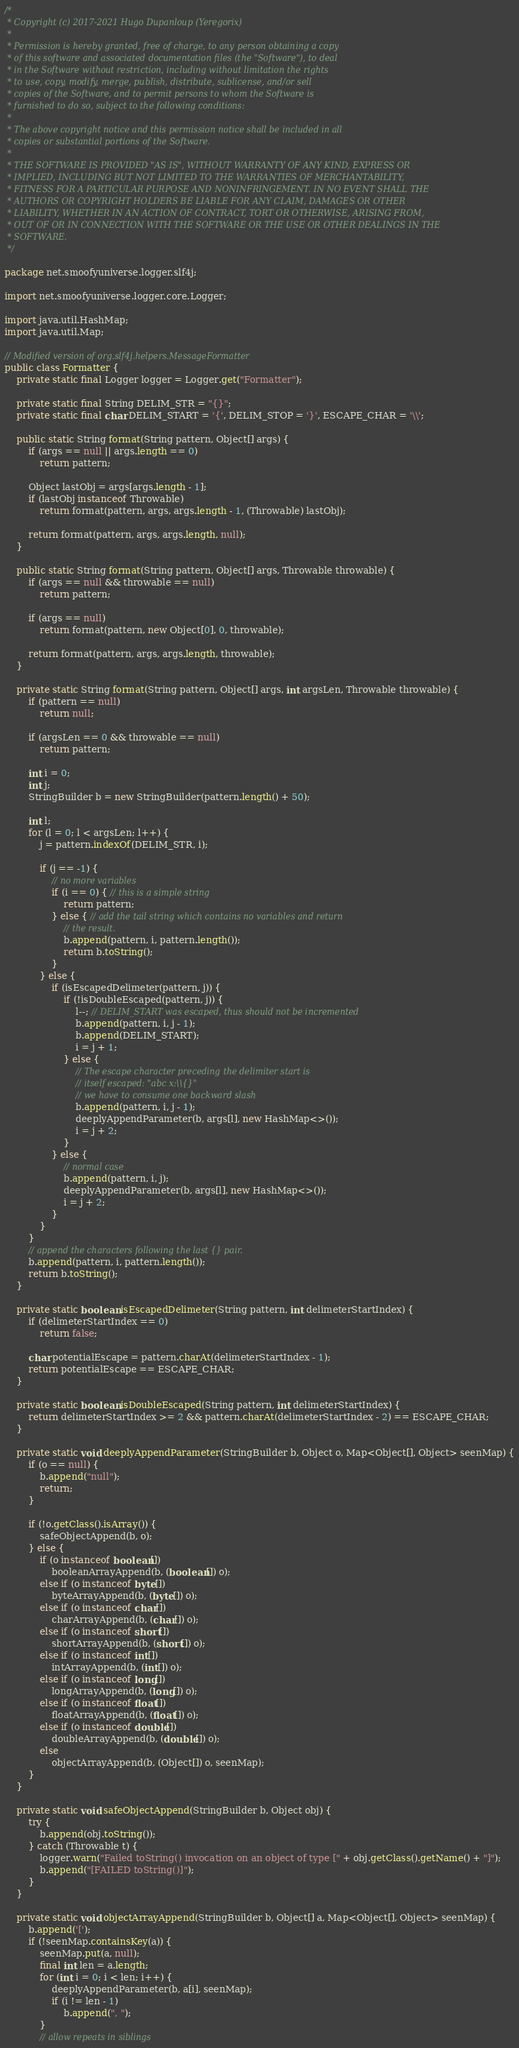<code> <loc_0><loc_0><loc_500><loc_500><_Java_>/*
 * Copyright (c) 2017-2021 Hugo Dupanloup (Yeregorix)
 *
 * Permission is hereby granted, free of charge, to any person obtaining a copy
 * of this software and associated documentation files (the "Software"), to deal
 * in the Software without restriction, including without limitation the rights
 * to use, copy, modify, merge, publish, distribute, sublicense, and/or sell
 * copies of the Software, and to permit persons to whom the Software is
 * furnished to do so, subject to the following conditions:
 *
 * The above copyright notice and this permission notice shall be included in all
 * copies or substantial portions of the Software.
 *
 * THE SOFTWARE IS PROVIDED "AS IS", WITHOUT WARRANTY OF ANY KIND, EXPRESS OR
 * IMPLIED, INCLUDING BUT NOT LIMITED TO THE WARRANTIES OF MERCHANTABILITY,
 * FITNESS FOR A PARTICULAR PURPOSE AND NONINFRINGEMENT. IN NO EVENT SHALL THE
 * AUTHORS OR COPYRIGHT HOLDERS BE LIABLE FOR ANY CLAIM, DAMAGES OR OTHER
 * LIABILITY, WHETHER IN AN ACTION OF CONTRACT, TORT OR OTHERWISE, ARISING FROM,
 * OUT OF OR IN CONNECTION WITH THE SOFTWARE OR THE USE OR OTHER DEALINGS IN THE
 * SOFTWARE.
 */

package net.smoofyuniverse.logger.slf4j;

import net.smoofyuniverse.logger.core.Logger;

import java.util.HashMap;
import java.util.Map;

// Modified version of org.slf4j.helpers.MessageFormatter
public class Formatter {
	private static final Logger logger = Logger.get("Formatter");

	private static final String DELIM_STR = "{}";
	private static final char DELIM_START = '{', DELIM_STOP = '}', ESCAPE_CHAR = '\\';

	public static String format(String pattern, Object[] args) {
		if (args == null || args.length == 0)
			return pattern;

		Object lastObj = args[args.length - 1];
		if (lastObj instanceof Throwable)
			return format(pattern, args, args.length - 1, (Throwable) lastObj);

		return format(pattern, args, args.length, null);
	}

	public static String format(String pattern, Object[] args, Throwable throwable) {
		if (args == null && throwable == null)
			return pattern;

		if (args == null)
			return format(pattern, new Object[0], 0, throwable);

		return format(pattern, args, args.length, throwable);
	}

	private static String format(String pattern, Object[] args, int argsLen, Throwable throwable) {
		if (pattern == null)
			return null;

		if (argsLen == 0 && throwable == null)
			return pattern;

		int i = 0;
		int j;
		StringBuilder b = new StringBuilder(pattern.length() + 50);

		int l;
		for (l = 0; l < argsLen; l++) {
			j = pattern.indexOf(DELIM_STR, i);

			if (j == -1) {
				// no more variables
				if (i == 0) { // this is a simple string
					return pattern;
				} else { // add the tail string which contains no variables and return
					// the result.
					b.append(pattern, i, pattern.length());
					return b.toString();
				}
			} else {
				if (isEscapedDelimeter(pattern, j)) {
					if (!isDoubleEscaped(pattern, j)) {
						l--; // DELIM_START was escaped, thus should not be incremented
						b.append(pattern, i, j - 1);
						b.append(DELIM_START);
						i = j + 1;
					} else {
						// The escape character preceding the delimiter start is
						// itself escaped: "abc x:\\{}"
						// we have to consume one backward slash
						b.append(pattern, i, j - 1);
						deeplyAppendParameter(b, args[l], new HashMap<>());
						i = j + 2;
					}
				} else {
					// normal case
					b.append(pattern, i, j);
					deeplyAppendParameter(b, args[l], new HashMap<>());
					i = j + 2;
				}
			}
		}
		// append the characters following the last {} pair.
		b.append(pattern, i, pattern.length());
		return b.toString();
	}

	private static boolean isEscapedDelimeter(String pattern, int delimeterStartIndex) {
		if (delimeterStartIndex == 0)
			return false;

		char potentialEscape = pattern.charAt(delimeterStartIndex - 1);
		return potentialEscape == ESCAPE_CHAR;
	}

	private static boolean isDoubleEscaped(String pattern, int delimeterStartIndex) {
		return delimeterStartIndex >= 2 && pattern.charAt(delimeterStartIndex - 2) == ESCAPE_CHAR;
	}

	private static void deeplyAppendParameter(StringBuilder b, Object o, Map<Object[], Object> seenMap) {
		if (o == null) {
			b.append("null");
			return;
		}

		if (!o.getClass().isArray()) {
			safeObjectAppend(b, o);
		} else {
			if (o instanceof boolean[])
				booleanArrayAppend(b, (boolean[]) o);
			else if (o instanceof byte[])
				byteArrayAppend(b, (byte[]) o);
			else if (o instanceof char[])
				charArrayAppend(b, (char[]) o);
			else if (o instanceof short[])
				shortArrayAppend(b, (short[]) o);
			else if (o instanceof int[])
				intArrayAppend(b, (int[]) o);
			else if (o instanceof long[])
				longArrayAppend(b, (long[]) o);
			else if (o instanceof float[])
				floatArrayAppend(b, (float[]) o);
			else if (o instanceof double[])
				doubleArrayAppend(b, (double[]) o);
			else
				objectArrayAppend(b, (Object[]) o, seenMap);
		}
	}

	private static void safeObjectAppend(StringBuilder b, Object obj) {
		try {
			b.append(obj.toString());
		} catch (Throwable t) {
			logger.warn("Failed toString() invocation on an object of type [" + obj.getClass().getName() + "]");
			b.append("[FAILED toString()]");
		}
	}

	private static void objectArrayAppend(StringBuilder b, Object[] a, Map<Object[], Object> seenMap) {
		b.append('[');
		if (!seenMap.containsKey(a)) {
			seenMap.put(a, null);
			final int len = a.length;
			for (int i = 0; i < len; i++) {
				deeplyAppendParameter(b, a[i], seenMap);
				if (i != len - 1)
					b.append(", ");
			}
			// allow repeats in siblings</code> 